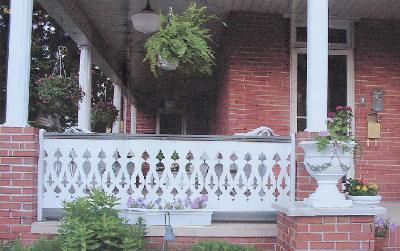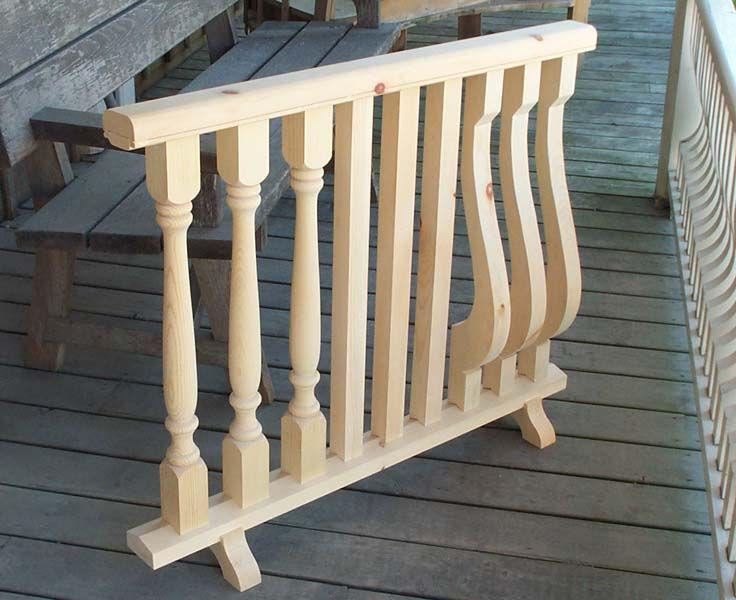The first image is the image on the left, the second image is the image on the right. For the images displayed, is the sentence "there is a decorative porch rail on the front porch, with the outside of the home visible and windows" factually correct? Answer yes or no. Yes. The first image is the image on the left, the second image is the image on the right. Given the left and right images, does the statement "The left image shows a white-painted rail with decorative geometric cut-outs instead of spindles, above red brick." hold true? Answer yes or no. Yes. 